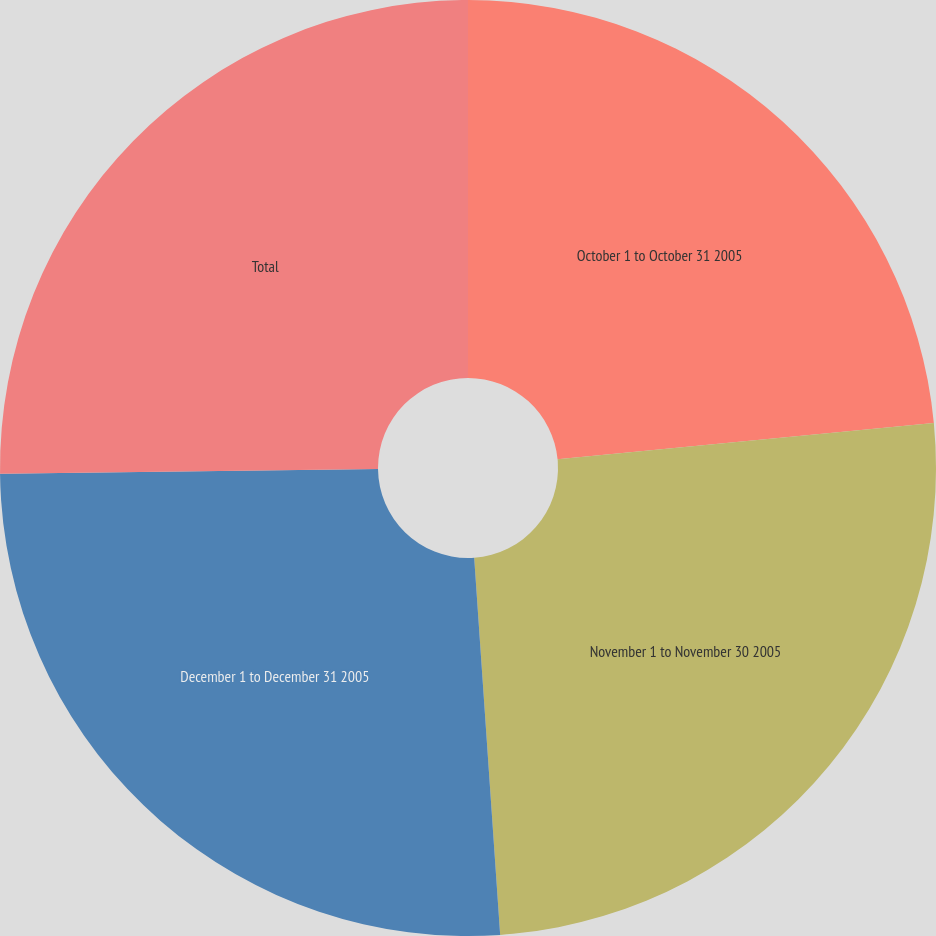Convert chart. <chart><loc_0><loc_0><loc_500><loc_500><pie_chart><fcel>October 1 to October 31 2005<fcel>November 1 to November 30 2005<fcel>December 1 to December 31 2005<fcel>Total<nl><fcel>23.47%<fcel>25.44%<fcel>25.9%<fcel>25.2%<nl></chart> 